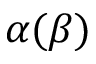Convert formula to latex. <formula><loc_0><loc_0><loc_500><loc_500>\alpha ( \beta )</formula> 